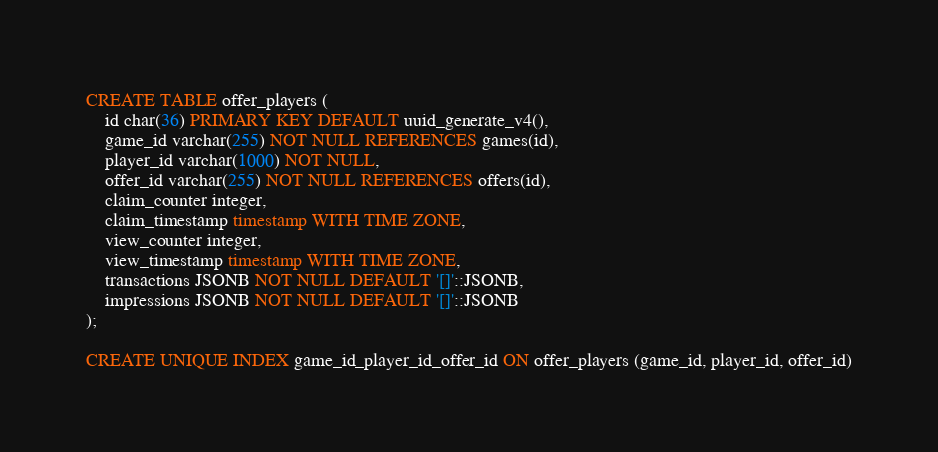Convert code to text. <code><loc_0><loc_0><loc_500><loc_500><_SQL_>CREATE TABLE offer_players (
    id char(36) PRIMARY KEY DEFAULT uuid_generate_v4(),
    game_id varchar(255) NOT NULL REFERENCES games(id),
    player_id varchar(1000) NOT NULL,
    offer_id varchar(255) NOT NULL REFERENCES offers(id),
    claim_counter integer,
    claim_timestamp timestamp WITH TIME ZONE,
    view_counter integer,
    view_timestamp timestamp WITH TIME ZONE,
    transactions JSONB NOT NULL DEFAULT '[]'::JSONB,
    impressions JSONB NOT NULL DEFAULT '[]'::JSONB
);

CREATE UNIQUE INDEX game_id_player_id_offer_id ON offer_players (game_id, player_id, offer_id)
</code> 